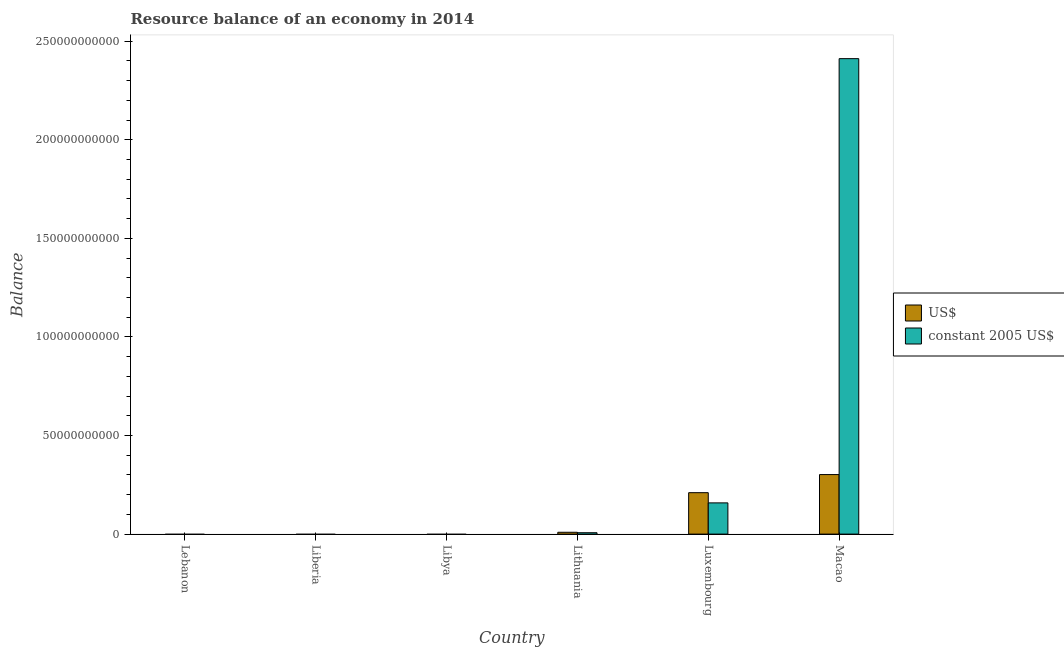How many different coloured bars are there?
Your answer should be compact. 2. Are the number of bars per tick equal to the number of legend labels?
Provide a succinct answer. No. Are the number of bars on each tick of the X-axis equal?
Provide a short and direct response. No. What is the label of the 4th group of bars from the left?
Ensure brevity in your answer.  Lithuania. What is the resource balance in constant us$ in Luxembourg?
Give a very brief answer. 1.58e+1. Across all countries, what is the maximum resource balance in constant us$?
Your answer should be very brief. 2.41e+11. In which country was the resource balance in constant us$ maximum?
Give a very brief answer. Macao. What is the total resource balance in constant us$ in the graph?
Your answer should be very brief. 2.58e+11. What is the difference between the resource balance in us$ in Lithuania and that in Luxembourg?
Provide a succinct answer. -2.01e+1. What is the difference between the resource balance in constant us$ in Lebanon and the resource balance in us$ in Lithuania?
Your answer should be compact. -9.30e+08. What is the average resource balance in constant us$ per country?
Give a very brief answer. 4.29e+1. What is the difference between the resource balance in constant us$ and resource balance in us$ in Luxembourg?
Make the answer very short. -5.17e+09. What is the ratio of the resource balance in us$ in Luxembourg to that in Macao?
Make the answer very short. 0.7. What is the difference between the highest and the second highest resource balance in constant us$?
Your answer should be compact. 2.25e+11. What is the difference between the highest and the lowest resource balance in constant us$?
Ensure brevity in your answer.  2.41e+11. How many bars are there?
Your answer should be compact. 6. Are all the bars in the graph horizontal?
Provide a short and direct response. No. What is the difference between two consecutive major ticks on the Y-axis?
Provide a succinct answer. 5.00e+1. Are the values on the major ticks of Y-axis written in scientific E-notation?
Ensure brevity in your answer.  No. How are the legend labels stacked?
Provide a short and direct response. Vertical. What is the title of the graph?
Provide a short and direct response. Resource balance of an economy in 2014. Does "Primary income" appear as one of the legend labels in the graph?
Offer a terse response. No. What is the label or title of the X-axis?
Your answer should be very brief. Country. What is the label or title of the Y-axis?
Keep it short and to the point. Balance. What is the Balance of US$ in Liberia?
Offer a terse response. 0. What is the Balance in constant 2005 US$ in Liberia?
Your answer should be compact. 0. What is the Balance of US$ in Libya?
Your answer should be compact. 0. What is the Balance of constant 2005 US$ in Libya?
Keep it short and to the point. 0. What is the Balance in US$ in Lithuania?
Give a very brief answer. 9.30e+08. What is the Balance of constant 2005 US$ in Lithuania?
Ensure brevity in your answer.  7.01e+08. What is the Balance in US$ in Luxembourg?
Your answer should be compact. 2.10e+1. What is the Balance of constant 2005 US$ in Luxembourg?
Give a very brief answer. 1.58e+1. What is the Balance in US$ in Macao?
Provide a succinct answer. 3.02e+1. What is the Balance in constant 2005 US$ in Macao?
Provide a succinct answer. 2.41e+11. Across all countries, what is the maximum Balance in US$?
Provide a succinct answer. 3.02e+1. Across all countries, what is the maximum Balance of constant 2005 US$?
Ensure brevity in your answer.  2.41e+11. What is the total Balance in US$ in the graph?
Make the answer very short. 5.21e+1. What is the total Balance of constant 2005 US$ in the graph?
Provide a short and direct response. 2.58e+11. What is the difference between the Balance of US$ in Lithuania and that in Luxembourg?
Provide a short and direct response. -2.01e+1. What is the difference between the Balance in constant 2005 US$ in Lithuania and that in Luxembourg?
Offer a very short reply. -1.51e+1. What is the difference between the Balance in US$ in Lithuania and that in Macao?
Your response must be concise. -2.93e+1. What is the difference between the Balance of constant 2005 US$ in Lithuania and that in Macao?
Your response must be concise. -2.40e+11. What is the difference between the Balance of US$ in Luxembourg and that in Macao?
Provide a short and direct response. -9.18e+09. What is the difference between the Balance in constant 2005 US$ in Luxembourg and that in Macao?
Provide a succinct answer. -2.25e+11. What is the difference between the Balance of US$ in Lithuania and the Balance of constant 2005 US$ in Luxembourg?
Provide a succinct answer. -1.49e+1. What is the difference between the Balance of US$ in Lithuania and the Balance of constant 2005 US$ in Macao?
Offer a very short reply. -2.40e+11. What is the difference between the Balance in US$ in Luxembourg and the Balance in constant 2005 US$ in Macao?
Keep it short and to the point. -2.20e+11. What is the average Balance in US$ per country?
Keep it short and to the point. 8.69e+09. What is the average Balance of constant 2005 US$ per country?
Keep it short and to the point. 4.29e+1. What is the difference between the Balance in US$ and Balance in constant 2005 US$ in Lithuania?
Keep it short and to the point. 2.29e+08. What is the difference between the Balance in US$ and Balance in constant 2005 US$ in Luxembourg?
Make the answer very short. 5.17e+09. What is the difference between the Balance of US$ and Balance of constant 2005 US$ in Macao?
Make the answer very short. -2.11e+11. What is the ratio of the Balance in US$ in Lithuania to that in Luxembourg?
Offer a terse response. 0.04. What is the ratio of the Balance of constant 2005 US$ in Lithuania to that in Luxembourg?
Offer a very short reply. 0.04. What is the ratio of the Balance in US$ in Lithuania to that in Macao?
Your answer should be very brief. 0.03. What is the ratio of the Balance in constant 2005 US$ in Lithuania to that in Macao?
Your answer should be very brief. 0. What is the ratio of the Balance in US$ in Luxembourg to that in Macao?
Give a very brief answer. 0.7. What is the ratio of the Balance in constant 2005 US$ in Luxembourg to that in Macao?
Your response must be concise. 0.07. What is the difference between the highest and the second highest Balance of US$?
Your answer should be very brief. 9.18e+09. What is the difference between the highest and the second highest Balance in constant 2005 US$?
Your answer should be compact. 2.25e+11. What is the difference between the highest and the lowest Balance in US$?
Give a very brief answer. 3.02e+1. What is the difference between the highest and the lowest Balance of constant 2005 US$?
Offer a very short reply. 2.41e+11. 